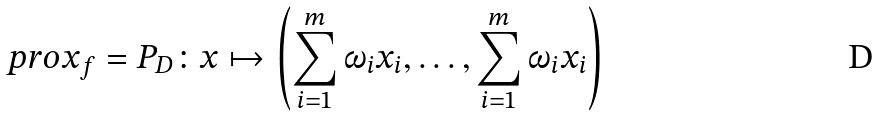<formula> <loc_0><loc_0><loc_500><loc_500>\ p r o x _ { f } = P _ { D } \colon x \mapsto \left ( \sum _ { i = 1 } ^ { m } \omega _ { i } x _ { i } , \dots , \sum _ { i = 1 } ^ { m } \omega _ { i } x _ { i } \right )</formula> 